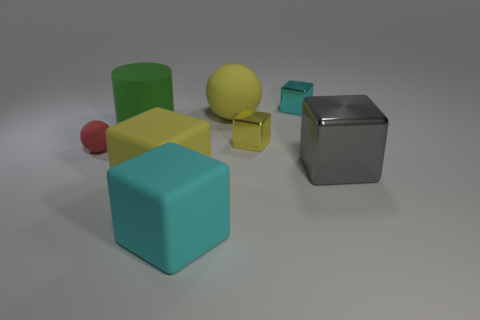How many purple things are either rubber things or spheres? In the image, there are no purple items. There are, however, a variety of colorful objects, none of which can be confirmed as rubber just by the image alone. 